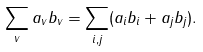<formula> <loc_0><loc_0><loc_500><loc_500>\sum _ { v } a _ { v } b _ { v } = \sum _ { i , j } ( a _ { i } b _ { i } + a _ { j } b _ { j } ) .</formula> 